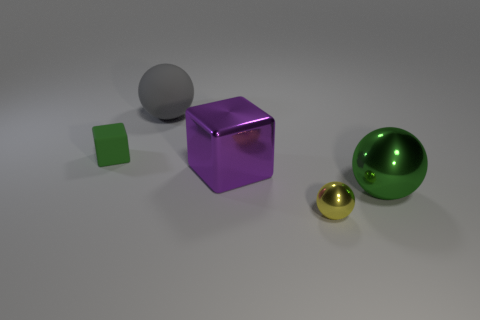What is the color of the ball that is both behind the yellow shiny thing and to the right of the gray sphere?
Ensure brevity in your answer.  Green. There is a object that is on the left side of the big matte object; is it the same size as the ball that is on the left side of the tiny ball?
Keep it short and to the point. No. What number of other things are there of the same size as the yellow metal thing?
Give a very brief answer. 1. There is a tiny object that is in front of the purple shiny thing; what number of tiny green matte cubes are in front of it?
Offer a very short reply. 0. Is the number of small rubber blocks behind the large purple object less than the number of small purple rubber things?
Offer a terse response. No. What shape is the green object that is on the right side of the matte thing that is on the right side of the cube that is left of the big gray object?
Make the answer very short. Sphere. Does the large green thing have the same shape as the large gray object?
Offer a very short reply. Yes. How many other things are there of the same shape as the big green object?
Ensure brevity in your answer.  2. The matte cube that is the same size as the yellow object is what color?
Provide a short and direct response. Green. Are there an equal number of green shiny objects that are in front of the big metallic ball and purple metallic cylinders?
Provide a succinct answer. Yes. 